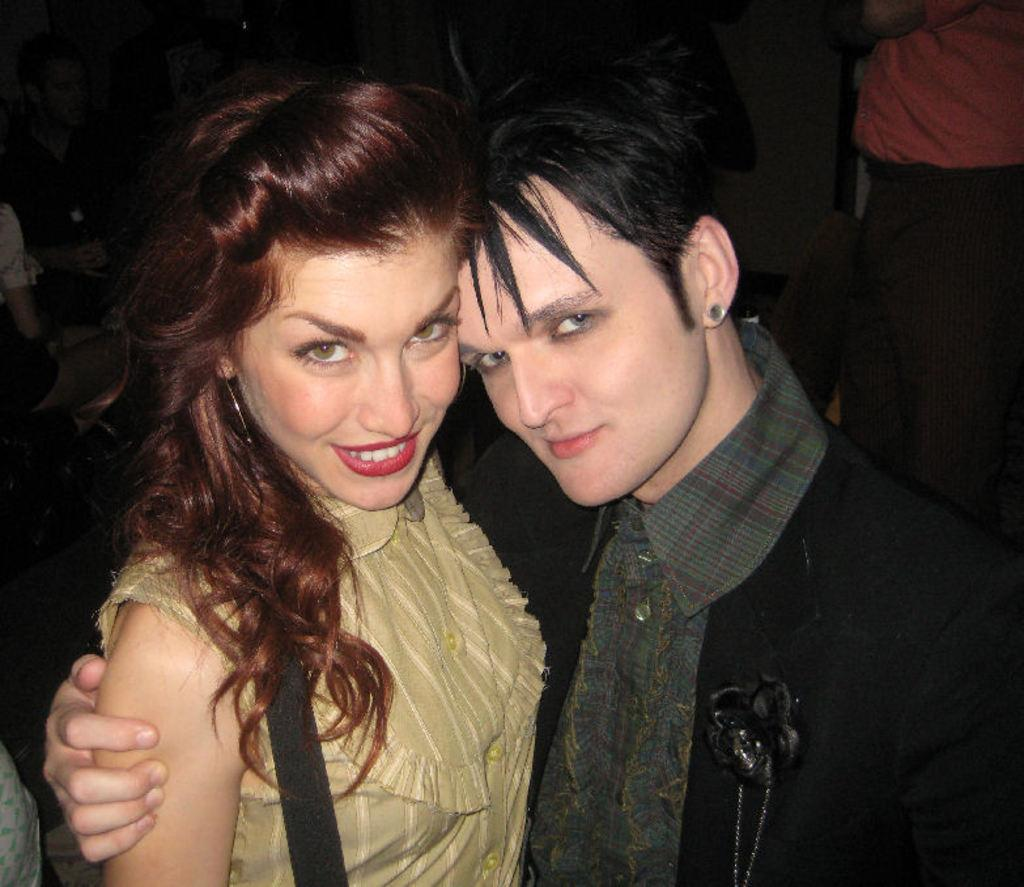Who is the main subject in the image? There is a woman in the image. What is the relationship between the woman and the person in front of her? The person is in front of the woman. What can be observed about the person's attire? The person is wearing a blazer. Can you describe the background of the image? There are people visible behind the woman and the person in front of her. What type of shoes is the woman wearing on stage in the image? There is no stage present in the image, and the woman's shoes are not visible. 